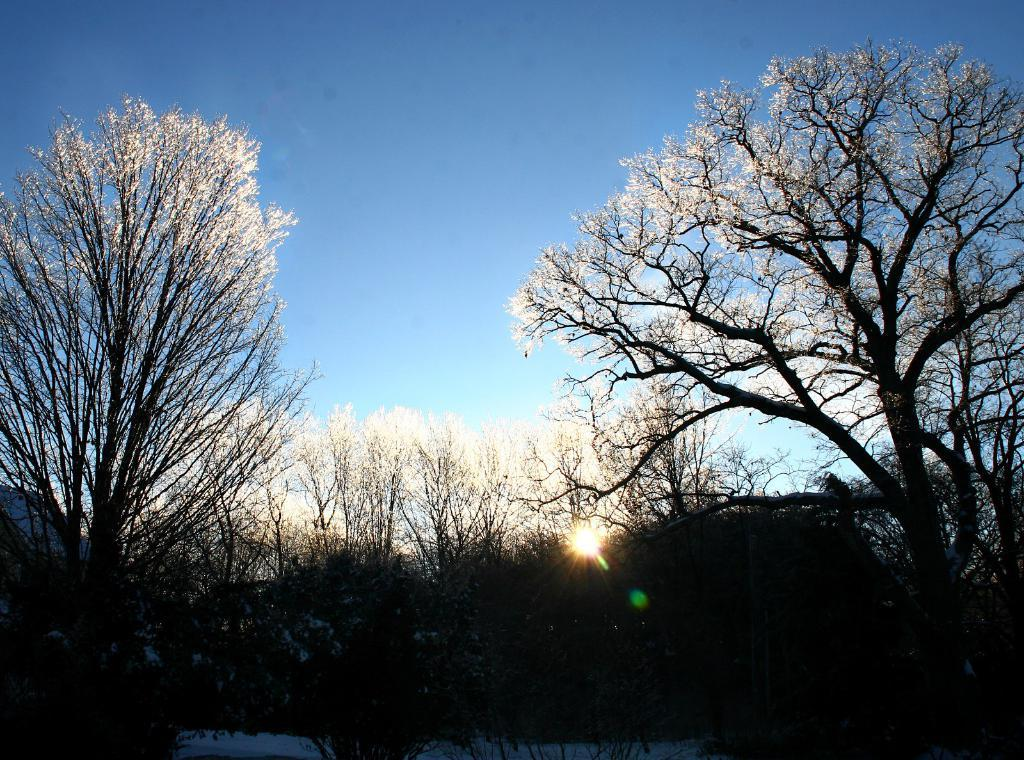What is the primary feature of the image? There are many trees in the image. What can be seen in the distance behind the trees? The sky is visible in the background of the image. What type of pipe is being used by the uncle in the image? There is no pipe or uncle present in the image; it features trees and the sky. 